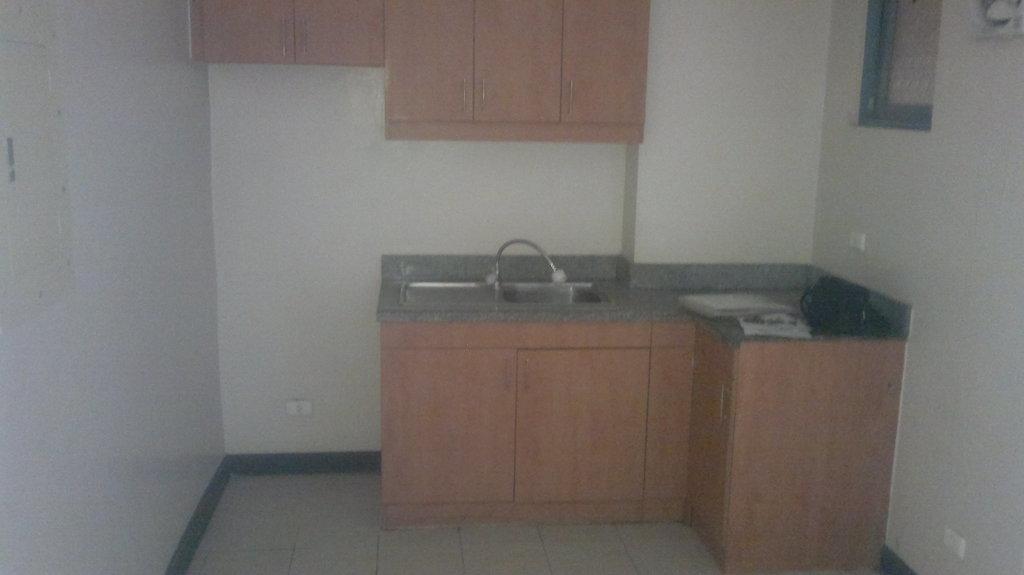Please provide a concise description of this image. In this image I can see a sink and a tap attached to it. Background I can see few cupboards in brown color and the wall is in cream color. 